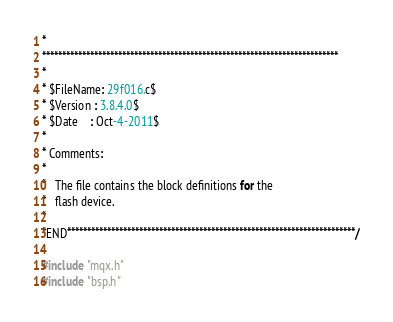<code> <loc_0><loc_0><loc_500><loc_500><_C_>*
**************************************************************************
*
* $FileName: 29f016.c$
* $Version : 3.8.4.0$
* $Date    : Oct-4-2011$
*
* Comments:
*
*   The file contains the block definitions for the
*   flash device.
*
*END************************************************************************/

#include "mqx.h" 
#include "bsp.h"</code> 